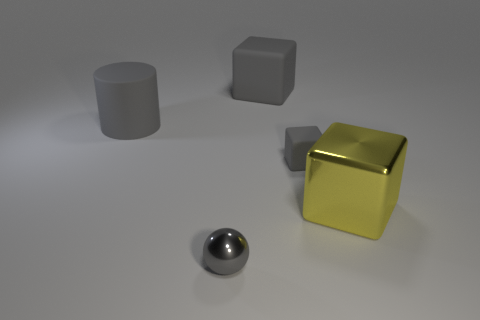There is a small gray object that is left of the small gray cube; how many gray matte cylinders are in front of it?
Provide a succinct answer. 0. Are there any other things that have the same color as the matte cylinder?
Your answer should be very brief. Yes. How many objects are either cyan matte objects or large matte things behind the tiny gray rubber object?
Provide a short and direct response. 2. There is a large yellow cube that is right of the large thing behind the matte object that is left of the small gray sphere; what is it made of?
Your answer should be compact. Metal. What size is the gray sphere that is made of the same material as the yellow thing?
Your answer should be very brief. Small. What is the color of the large matte thing that is on the right side of the gray matte object that is on the left side of the shiny ball?
Your answer should be very brief. Gray. What number of tiny gray things are the same material as the yellow object?
Offer a very short reply. 1. What number of rubber things are small gray cylinders or big yellow cubes?
Keep it short and to the point. 0. There is a object that is the same size as the metallic ball; what material is it?
Keep it short and to the point. Rubber. Is there another tiny yellow object made of the same material as the yellow object?
Provide a short and direct response. No. 